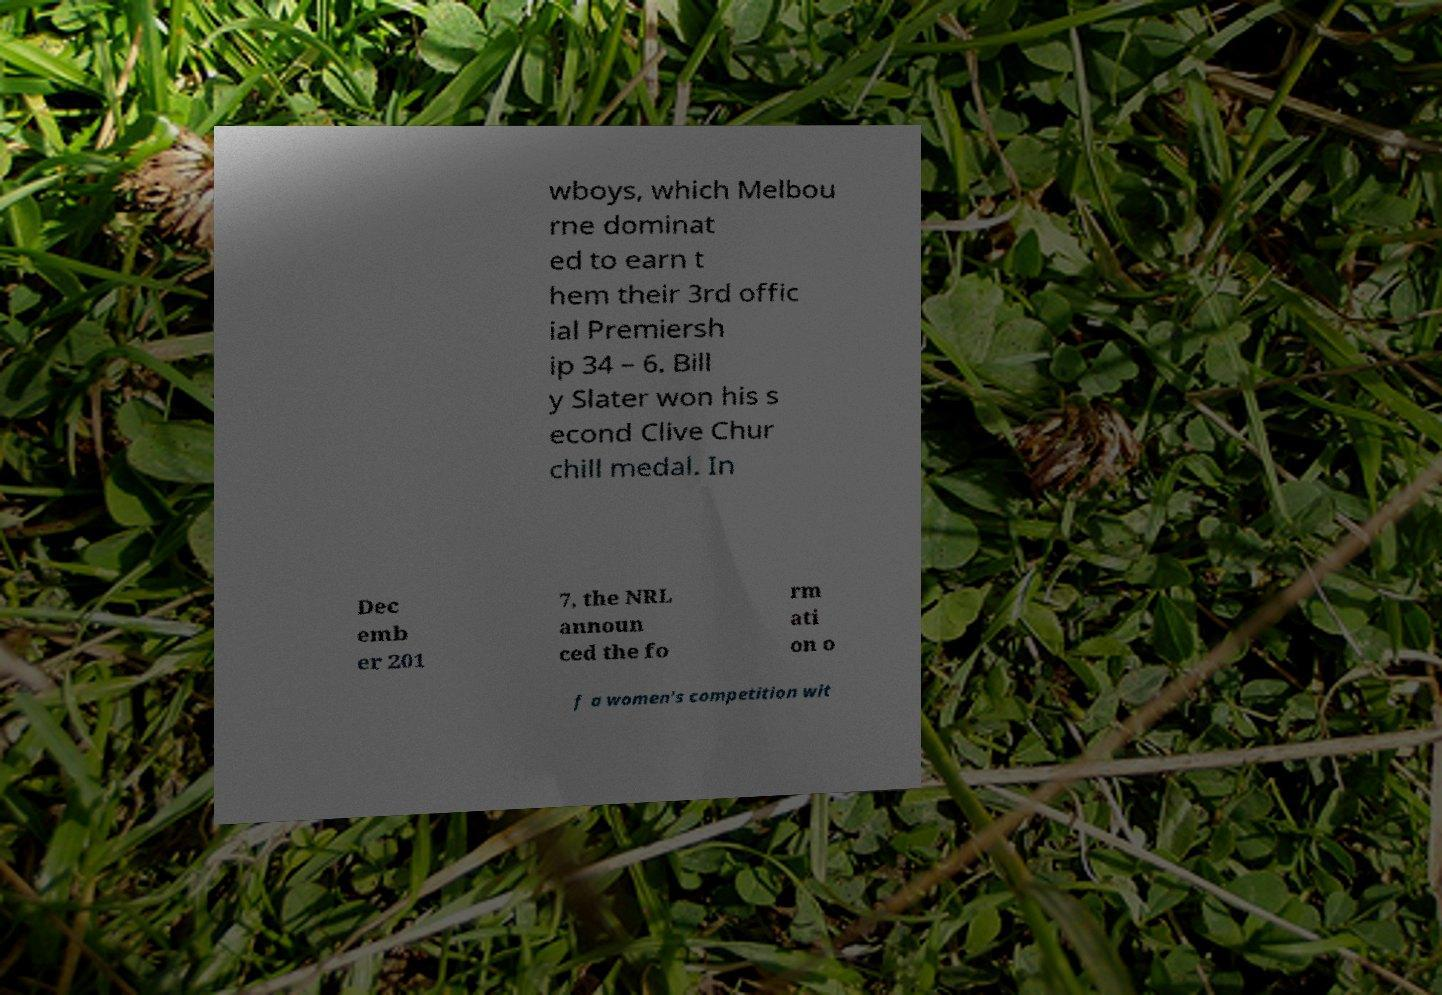Please identify and transcribe the text found in this image. wboys, which Melbou rne dominat ed to earn t hem their 3rd offic ial Premiersh ip 34 – 6. Bill y Slater won his s econd Clive Chur chill medal. In Dec emb er 201 7, the NRL announ ced the fo rm ati on o f a women's competition wit 